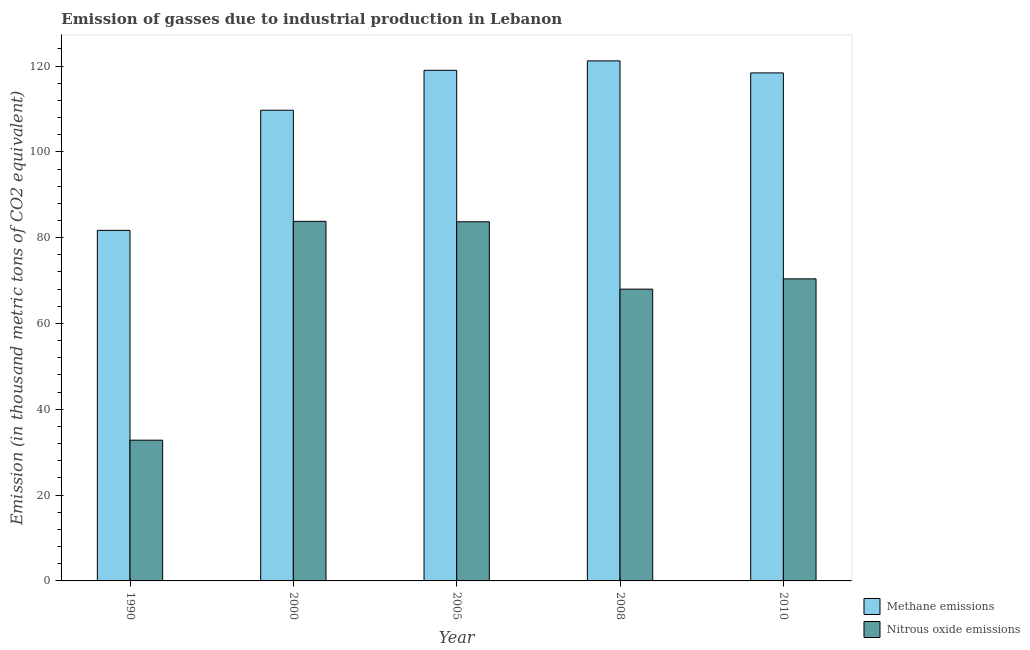How many different coloured bars are there?
Your answer should be very brief. 2. How many bars are there on the 1st tick from the left?
Give a very brief answer. 2. What is the amount of methane emissions in 2000?
Your answer should be compact. 109.7. Across all years, what is the maximum amount of methane emissions?
Give a very brief answer. 121.2. Across all years, what is the minimum amount of methane emissions?
Your answer should be compact. 81.7. In which year was the amount of methane emissions minimum?
Give a very brief answer. 1990. What is the total amount of nitrous oxide emissions in the graph?
Ensure brevity in your answer.  338.7. What is the difference between the amount of methane emissions in 2000 and that in 2010?
Give a very brief answer. -8.7. What is the difference between the amount of nitrous oxide emissions in 1990 and the amount of methane emissions in 2010?
Ensure brevity in your answer.  -37.6. What is the average amount of methane emissions per year?
Make the answer very short. 110. In the year 2000, what is the difference between the amount of methane emissions and amount of nitrous oxide emissions?
Keep it short and to the point. 0. What is the ratio of the amount of nitrous oxide emissions in 2000 to that in 2010?
Your response must be concise. 1.19. What is the difference between the highest and the second highest amount of nitrous oxide emissions?
Offer a very short reply. 0.1. What is the difference between the highest and the lowest amount of methane emissions?
Ensure brevity in your answer.  39.5. In how many years, is the amount of nitrous oxide emissions greater than the average amount of nitrous oxide emissions taken over all years?
Ensure brevity in your answer.  4. Is the sum of the amount of nitrous oxide emissions in 2000 and 2005 greater than the maximum amount of methane emissions across all years?
Your response must be concise. Yes. What does the 1st bar from the left in 2000 represents?
Your answer should be compact. Methane emissions. What does the 1st bar from the right in 2005 represents?
Keep it short and to the point. Nitrous oxide emissions. Are all the bars in the graph horizontal?
Ensure brevity in your answer.  No. How many years are there in the graph?
Offer a terse response. 5. Are the values on the major ticks of Y-axis written in scientific E-notation?
Provide a short and direct response. No. Does the graph contain any zero values?
Ensure brevity in your answer.  No. Where does the legend appear in the graph?
Provide a succinct answer. Bottom right. How are the legend labels stacked?
Make the answer very short. Vertical. What is the title of the graph?
Offer a very short reply. Emission of gasses due to industrial production in Lebanon. What is the label or title of the X-axis?
Keep it short and to the point. Year. What is the label or title of the Y-axis?
Your response must be concise. Emission (in thousand metric tons of CO2 equivalent). What is the Emission (in thousand metric tons of CO2 equivalent) in Methane emissions in 1990?
Provide a succinct answer. 81.7. What is the Emission (in thousand metric tons of CO2 equivalent) of Nitrous oxide emissions in 1990?
Offer a very short reply. 32.8. What is the Emission (in thousand metric tons of CO2 equivalent) in Methane emissions in 2000?
Your response must be concise. 109.7. What is the Emission (in thousand metric tons of CO2 equivalent) of Nitrous oxide emissions in 2000?
Give a very brief answer. 83.8. What is the Emission (in thousand metric tons of CO2 equivalent) in Methane emissions in 2005?
Provide a succinct answer. 119. What is the Emission (in thousand metric tons of CO2 equivalent) in Nitrous oxide emissions in 2005?
Provide a short and direct response. 83.7. What is the Emission (in thousand metric tons of CO2 equivalent) in Methane emissions in 2008?
Your answer should be very brief. 121.2. What is the Emission (in thousand metric tons of CO2 equivalent) of Nitrous oxide emissions in 2008?
Make the answer very short. 68. What is the Emission (in thousand metric tons of CO2 equivalent) of Methane emissions in 2010?
Ensure brevity in your answer.  118.4. What is the Emission (in thousand metric tons of CO2 equivalent) of Nitrous oxide emissions in 2010?
Your response must be concise. 70.4. Across all years, what is the maximum Emission (in thousand metric tons of CO2 equivalent) of Methane emissions?
Ensure brevity in your answer.  121.2. Across all years, what is the maximum Emission (in thousand metric tons of CO2 equivalent) in Nitrous oxide emissions?
Ensure brevity in your answer.  83.8. Across all years, what is the minimum Emission (in thousand metric tons of CO2 equivalent) of Methane emissions?
Offer a terse response. 81.7. Across all years, what is the minimum Emission (in thousand metric tons of CO2 equivalent) in Nitrous oxide emissions?
Provide a succinct answer. 32.8. What is the total Emission (in thousand metric tons of CO2 equivalent) in Methane emissions in the graph?
Your response must be concise. 550. What is the total Emission (in thousand metric tons of CO2 equivalent) in Nitrous oxide emissions in the graph?
Give a very brief answer. 338.7. What is the difference between the Emission (in thousand metric tons of CO2 equivalent) of Nitrous oxide emissions in 1990 and that in 2000?
Your answer should be compact. -51. What is the difference between the Emission (in thousand metric tons of CO2 equivalent) of Methane emissions in 1990 and that in 2005?
Provide a short and direct response. -37.3. What is the difference between the Emission (in thousand metric tons of CO2 equivalent) of Nitrous oxide emissions in 1990 and that in 2005?
Your answer should be compact. -50.9. What is the difference between the Emission (in thousand metric tons of CO2 equivalent) in Methane emissions in 1990 and that in 2008?
Offer a very short reply. -39.5. What is the difference between the Emission (in thousand metric tons of CO2 equivalent) in Nitrous oxide emissions in 1990 and that in 2008?
Keep it short and to the point. -35.2. What is the difference between the Emission (in thousand metric tons of CO2 equivalent) in Methane emissions in 1990 and that in 2010?
Your answer should be compact. -36.7. What is the difference between the Emission (in thousand metric tons of CO2 equivalent) of Nitrous oxide emissions in 1990 and that in 2010?
Your answer should be very brief. -37.6. What is the difference between the Emission (in thousand metric tons of CO2 equivalent) in Nitrous oxide emissions in 2000 and that in 2005?
Your response must be concise. 0.1. What is the difference between the Emission (in thousand metric tons of CO2 equivalent) of Methane emissions in 2000 and that in 2008?
Make the answer very short. -11.5. What is the difference between the Emission (in thousand metric tons of CO2 equivalent) in Nitrous oxide emissions in 2000 and that in 2008?
Your answer should be very brief. 15.8. What is the difference between the Emission (in thousand metric tons of CO2 equivalent) of Methane emissions in 2000 and that in 2010?
Offer a very short reply. -8.7. What is the difference between the Emission (in thousand metric tons of CO2 equivalent) of Methane emissions in 2005 and that in 2008?
Ensure brevity in your answer.  -2.2. What is the difference between the Emission (in thousand metric tons of CO2 equivalent) of Nitrous oxide emissions in 2008 and that in 2010?
Provide a short and direct response. -2.4. What is the difference between the Emission (in thousand metric tons of CO2 equivalent) in Methane emissions in 1990 and the Emission (in thousand metric tons of CO2 equivalent) in Nitrous oxide emissions in 2008?
Provide a short and direct response. 13.7. What is the difference between the Emission (in thousand metric tons of CO2 equivalent) of Methane emissions in 1990 and the Emission (in thousand metric tons of CO2 equivalent) of Nitrous oxide emissions in 2010?
Your answer should be very brief. 11.3. What is the difference between the Emission (in thousand metric tons of CO2 equivalent) of Methane emissions in 2000 and the Emission (in thousand metric tons of CO2 equivalent) of Nitrous oxide emissions in 2005?
Provide a succinct answer. 26. What is the difference between the Emission (in thousand metric tons of CO2 equivalent) in Methane emissions in 2000 and the Emission (in thousand metric tons of CO2 equivalent) in Nitrous oxide emissions in 2008?
Provide a short and direct response. 41.7. What is the difference between the Emission (in thousand metric tons of CO2 equivalent) of Methane emissions in 2000 and the Emission (in thousand metric tons of CO2 equivalent) of Nitrous oxide emissions in 2010?
Give a very brief answer. 39.3. What is the difference between the Emission (in thousand metric tons of CO2 equivalent) of Methane emissions in 2005 and the Emission (in thousand metric tons of CO2 equivalent) of Nitrous oxide emissions in 2008?
Make the answer very short. 51. What is the difference between the Emission (in thousand metric tons of CO2 equivalent) of Methane emissions in 2005 and the Emission (in thousand metric tons of CO2 equivalent) of Nitrous oxide emissions in 2010?
Offer a terse response. 48.6. What is the difference between the Emission (in thousand metric tons of CO2 equivalent) in Methane emissions in 2008 and the Emission (in thousand metric tons of CO2 equivalent) in Nitrous oxide emissions in 2010?
Ensure brevity in your answer.  50.8. What is the average Emission (in thousand metric tons of CO2 equivalent) of Methane emissions per year?
Provide a short and direct response. 110. What is the average Emission (in thousand metric tons of CO2 equivalent) in Nitrous oxide emissions per year?
Your answer should be compact. 67.74. In the year 1990, what is the difference between the Emission (in thousand metric tons of CO2 equivalent) of Methane emissions and Emission (in thousand metric tons of CO2 equivalent) of Nitrous oxide emissions?
Keep it short and to the point. 48.9. In the year 2000, what is the difference between the Emission (in thousand metric tons of CO2 equivalent) of Methane emissions and Emission (in thousand metric tons of CO2 equivalent) of Nitrous oxide emissions?
Your answer should be very brief. 25.9. In the year 2005, what is the difference between the Emission (in thousand metric tons of CO2 equivalent) in Methane emissions and Emission (in thousand metric tons of CO2 equivalent) in Nitrous oxide emissions?
Offer a very short reply. 35.3. In the year 2008, what is the difference between the Emission (in thousand metric tons of CO2 equivalent) of Methane emissions and Emission (in thousand metric tons of CO2 equivalent) of Nitrous oxide emissions?
Offer a very short reply. 53.2. In the year 2010, what is the difference between the Emission (in thousand metric tons of CO2 equivalent) in Methane emissions and Emission (in thousand metric tons of CO2 equivalent) in Nitrous oxide emissions?
Your response must be concise. 48. What is the ratio of the Emission (in thousand metric tons of CO2 equivalent) of Methane emissions in 1990 to that in 2000?
Make the answer very short. 0.74. What is the ratio of the Emission (in thousand metric tons of CO2 equivalent) of Nitrous oxide emissions in 1990 to that in 2000?
Make the answer very short. 0.39. What is the ratio of the Emission (in thousand metric tons of CO2 equivalent) of Methane emissions in 1990 to that in 2005?
Your answer should be compact. 0.69. What is the ratio of the Emission (in thousand metric tons of CO2 equivalent) of Nitrous oxide emissions in 1990 to that in 2005?
Your answer should be very brief. 0.39. What is the ratio of the Emission (in thousand metric tons of CO2 equivalent) of Methane emissions in 1990 to that in 2008?
Your response must be concise. 0.67. What is the ratio of the Emission (in thousand metric tons of CO2 equivalent) of Nitrous oxide emissions in 1990 to that in 2008?
Keep it short and to the point. 0.48. What is the ratio of the Emission (in thousand metric tons of CO2 equivalent) in Methane emissions in 1990 to that in 2010?
Offer a terse response. 0.69. What is the ratio of the Emission (in thousand metric tons of CO2 equivalent) of Nitrous oxide emissions in 1990 to that in 2010?
Your answer should be compact. 0.47. What is the ratio of the Emission (in thousand metric tons of CO2 equivalent) in Methane emissions in 2000 to that in 2005?
Ensure brevity in your answer.  0.92. What is the ratio of the Emission (in thousand metric tons of CO2 equivalent) of Methane emissions in 2000 to that in 2008?
Make the answer very short. 0.91. What is the ratio of the Emission (in thousand metric tons of CO2 equivalent) of Nitrous oxide emissions in 2000 to that in 2008?
Your answer should be very brief. 1.23. What is the ratio of the Emission (in thousand metric tons of CO2 equivalent) of Methane emissions in 2000 to that in 2010?
Ensure brevity in your answer.  0.93. What is the ratio of the Emission (in thousand metric tons of CO2 equivalent) in Nitrous oxide emissions in 2000 to that in 2010?
Provide a short and direct response. 1.19. What is the ratio of the Emission (in thousand metric tons of CO2 equivalent) of Methane emissions in 2005 to that in 2008?
Keep it short and to the point. 0.98. What is the ratio of the Emission (in thousand metric tons of CO2 equivalent) of Nitrous oxide emissions in 2005 to that in 2008?
Your answer should be compact. 1.23. What is the ratio of the Emission (in thousand metric tons of CO2 equivalent) in Methane emissions in 2005 to that in 2010?
Your answer should be compact. 1.01. What is the ratio of the Emission (in thousand metric tons of CO2 equivalent) in Nitrous oxide emissions in 2005 to that in 2010?
Offer a very short reply. 1.19. What is the ratio of the Emission (in thousand metric tons of CO2 equivalent) in Methane emissions in 2008 to that in 2010?
Make the answer very short. 1.02. What is the ratio of the Emission (in thousand metric tons of CO2 equivalent) of Nitrous oxide emissions in 2008 to that in 2010?
Keep it short and to the point. 0.97. What is the difference between the highest and the second highest Emission (in thousand metric tons of CO2 equivalent) in Nitrous oxide emissions?
Offer a terse response. 0.1. What is the difference between the highest and the lowest Emission (in thousand metric tons of CO2 equivalent) in Methane emissions?
Provide a short and direct response. 39.5. What is the difference between the highest and the lowest Emission (in thousand metric tons of CO2 equivalent) of Nitrous oxide emissions?
Offer a very short reply. 51. 